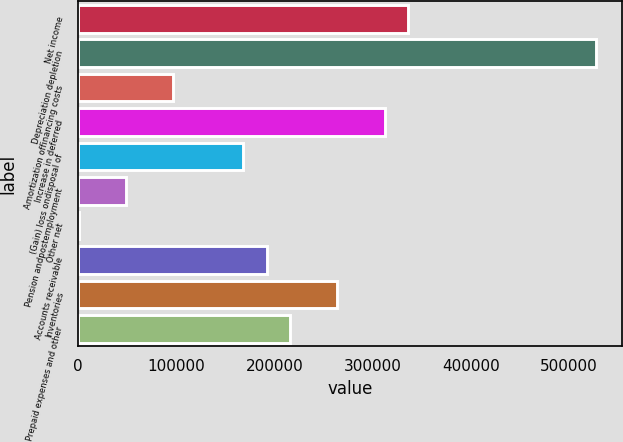<chart> <loc_0><loc_0><loc_500><loc_500><bar_chart><fcel>Net income<fcel>Depreciation depletion<fcel>Amortization offinancing costs<fcel>Increase in deferred<fcel>(Gain) loss ondisposal of<fcel>Pension andpostemployment<fcel>Other net<fcel>Accounts receivable<fcel>Inventories<fcel>Prepaid expenses and other<nl><fcel>335875<fcel>527592<fcel>96227.8<fcel>311910<fcel>168122<fcel>48298.4<fcel>369<fcel>192087<fcel>263981<fcel>216051<nl></chart> 